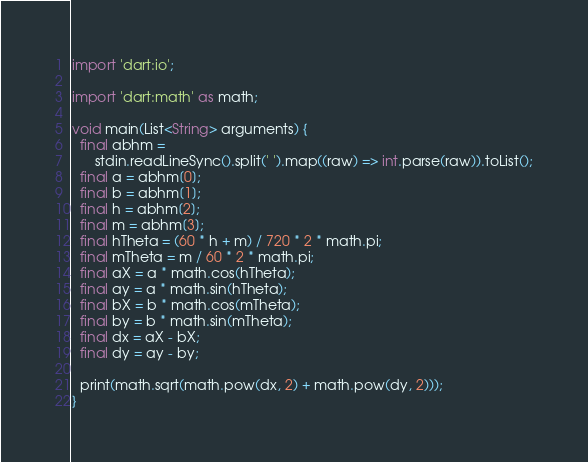<code> <loc_0><loc_0><loc_500><loc_500><_Dart_>import 'dart:io';

import 'dart:math' as math;

void main(List<String> arguments) {
  final abhm =
      stdin.readLineSync().split(' ').map((raw) => int.parse(raw)).toList();
  final a = abhm[0];
  final b = abhm[1];
  final h = abhm[2];
  final m = abhm[3];
  final hTheta = (60 * h + m) / 720 * 2 * math.pi;
  final mTheta = m / 60 * 2 * math.pi;
  final aX = a * math.cos(hTheta);
  final ay = a * math.sin(hTheta);
  final bX = b * math.cos(mTheta);
  final by = b * math.sin(mTheta);
  final dx = aX - bX;
  final dy = ay - by;

  print(math.sqrt(math.pow(dx, 2) + math.pow(dy, 2)));
}
</code> 